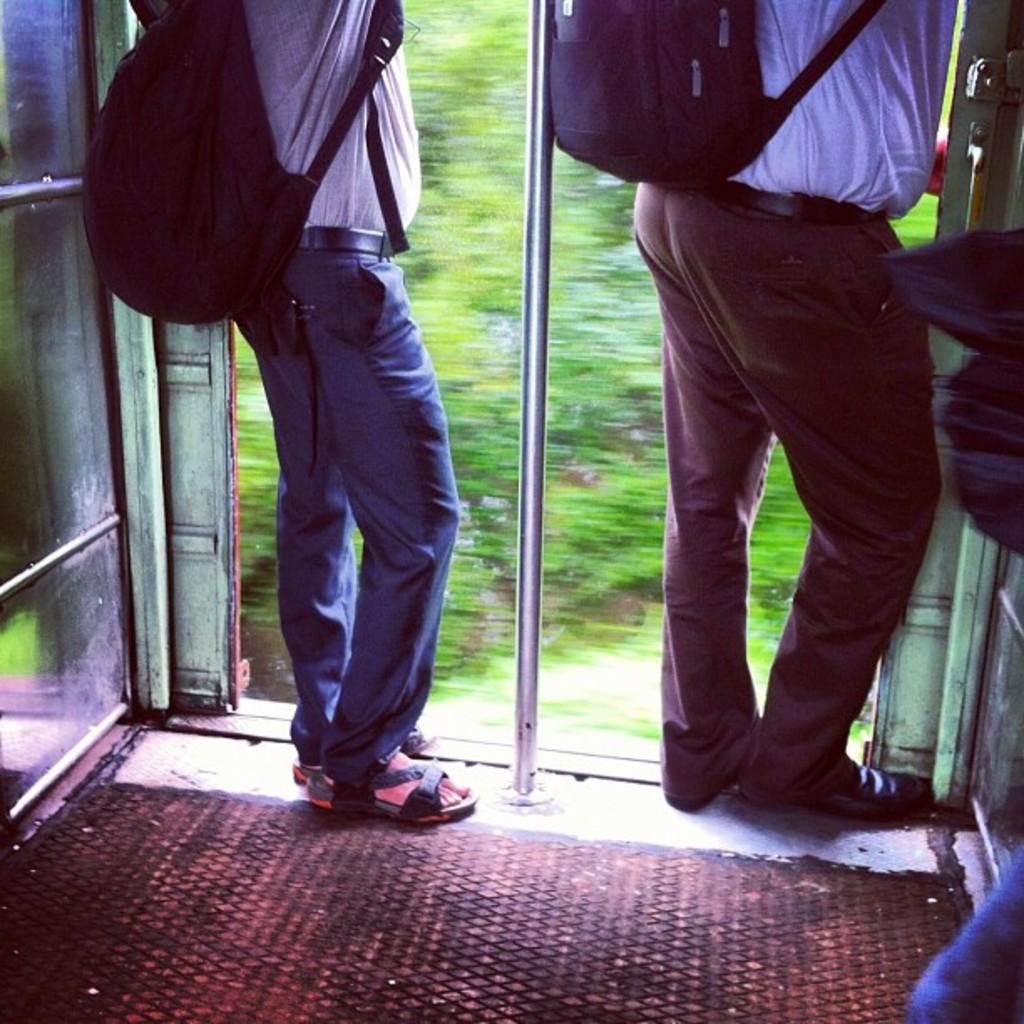How would you summarize this image in a sentence or two? In this image, we can see an inside view of a train. There are two persons wearing clothes and bags. There is a pole in the middle of the image. 